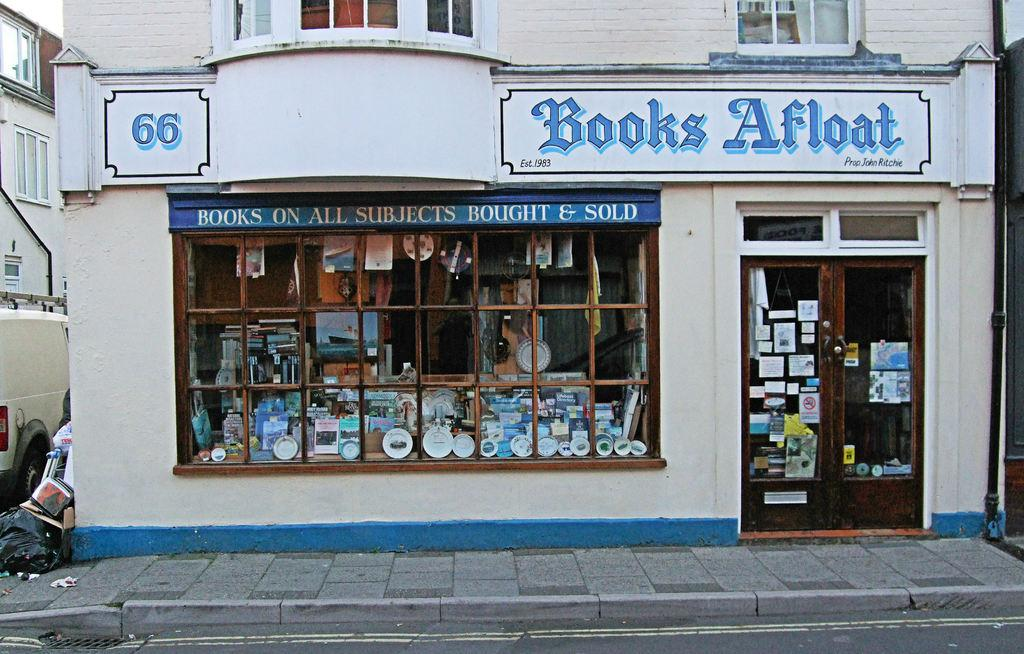<image>
Create a compact narrative representing the image presented. Outside of a small book store with windows showing the books named Books Afloat. 